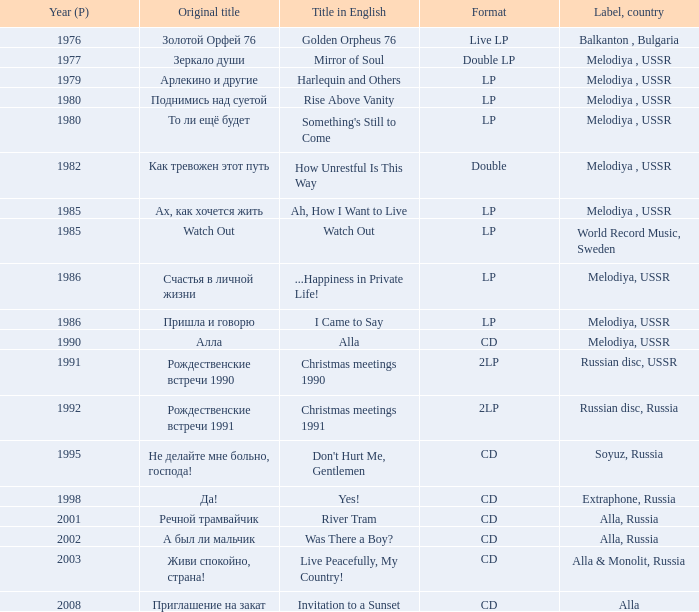What is the english title with a lp format and an Original title of то ли ещё будет? Something's Still to Come. 